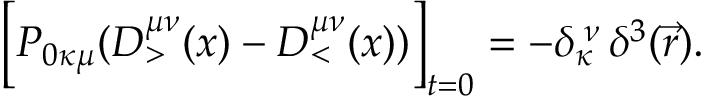<formula> <loc_0><loc_0><loc_500><loc_500>\left [ P _ { 0 \kappa \mu } ( D _ { > } ^ { \mu \nu } ( x ) - D _ { < } ^ { \mu \nu } ( x ) ) \right ] _ { t = 0 } = - \delta _ { \kappa } ^ { \, \nu } \, \delta ^ { 3 } ( \vec { r } ) .</formula> 